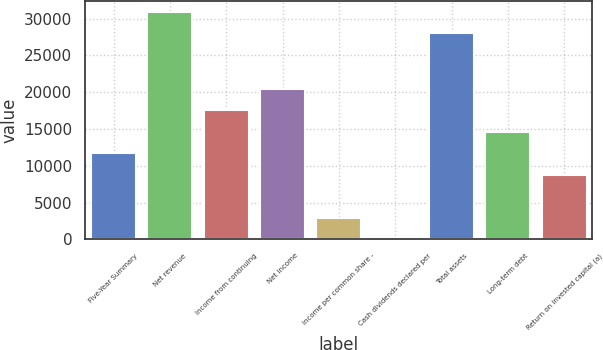Convert chart to OTSL. <chart><loc_0><loc_0><loc_500><loc_500><bar_chart><fcel>Five-Year Summary<fcel>Net revenue<fcel>Income from continuing<fcel>Net income<fcel>Income per common share -<fcel>Cash dividends declared per<fcel>Total assets<fcel>Long-term debt<fcel>Return on invested capital (a)<nl><fcel>11704.9<fcel>30913<fcel>17557<fcel>20483<fcel>2926.87<fcel>0.85<fcel>27987<fcel>14630.9<fcel>8778.91<nl></chart> 